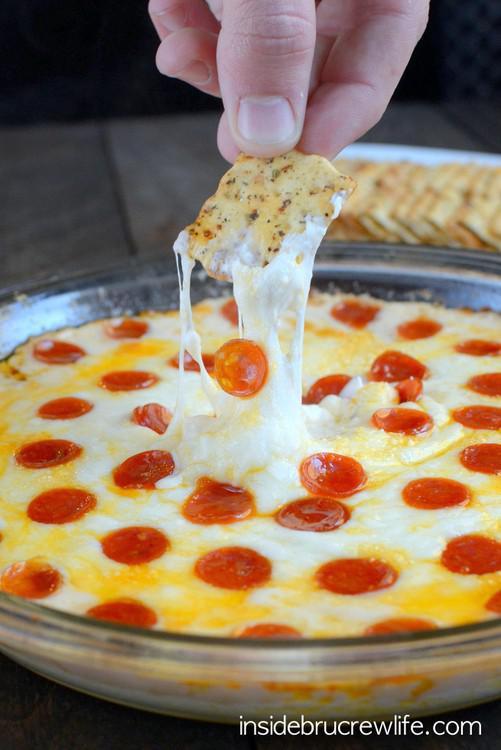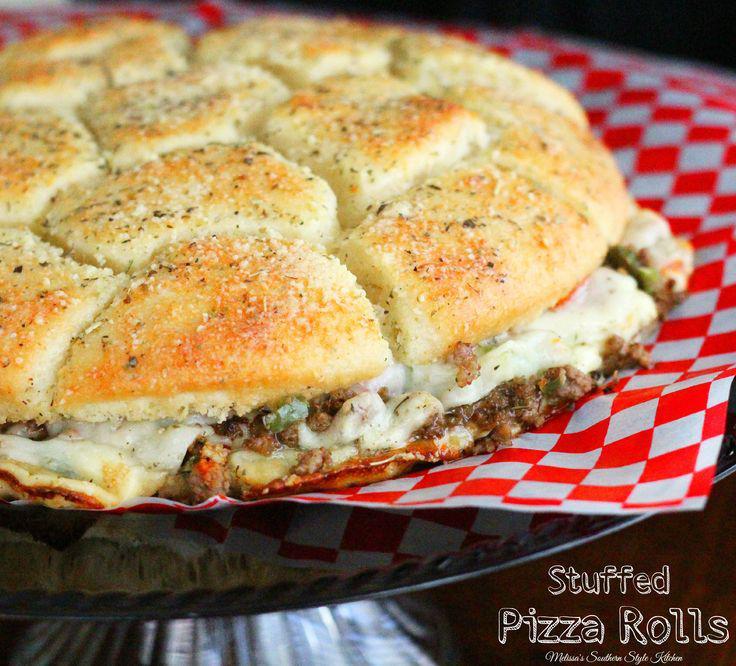The first image is the image on the left, the second image is the image on the right. Evaluate the accuracy of this statement regarding the images: "At least one of the pizzas contains pepperoni.". Is it true? Answer yes or no. Yes. 